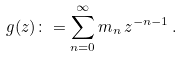Convert formula to latex. <formula><loc_0><loc_0><loc_500><loc_500>g ( z ) \colon = \sum _ { n = 0 } ^ { \infty } m _ { n } \, z ^ { - n - 1 } \, .</formula> 